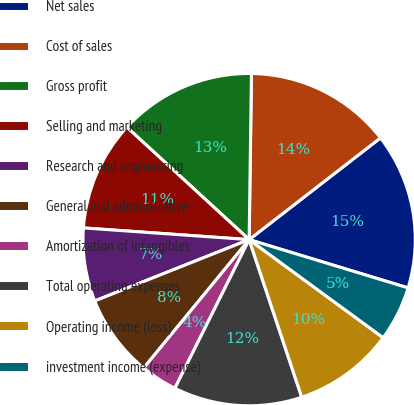Convert chart to OTSL. <chart><loc_0><loc_0><loc_500><loc_500><pie_chart><fcel>Net sales<fcel>Cost of sales<fcel>Gross profit<fcel>Selling and marketing<fcel>Research and engineering<fcel>General and administrative<fcel>Amortization of intangibles<fcel>Total operating expenses<fcel>Operating income (loss)<fcel>investment income (expense)<nl><fcel>15.18%<fcel>14.29%<fcel>13.39%<fcel>10.71%<fcel>7.14%<fcel>8.04%<fcel>3.57%<fcel>12.5%<fcel>9.82%<fcel>5.36%<nl></chart> 